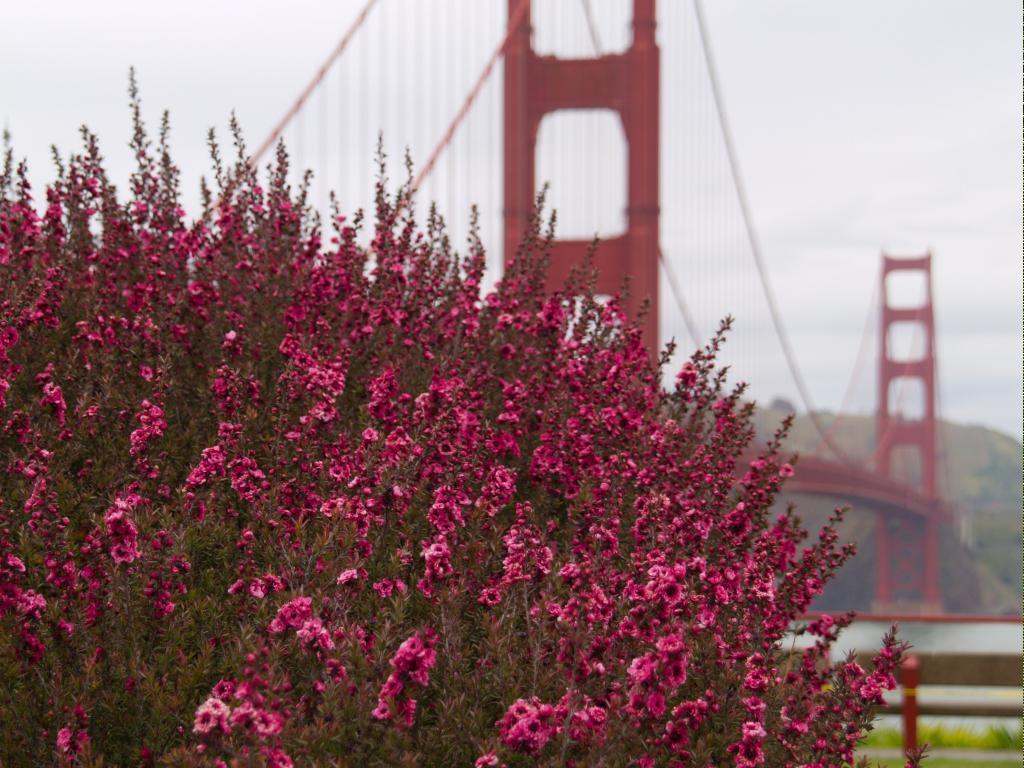Describe this image in one or two sentences. This image is clicked outside. There is a bridge in the middle. There is sky at the top. There is a tree in the middle. It has pink flowers. 